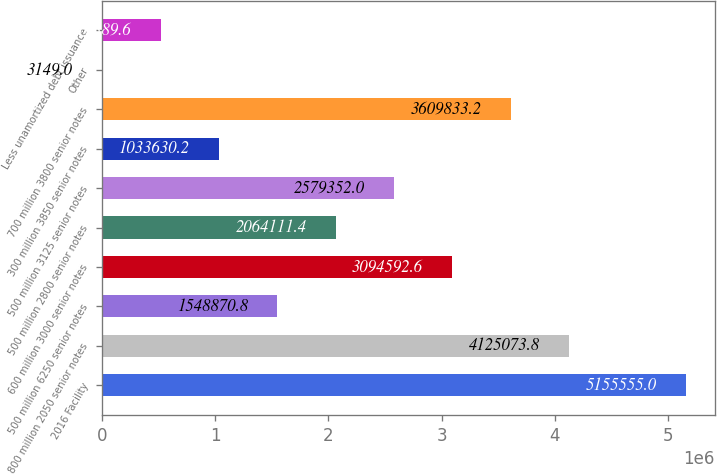Convert chart to OTSL. <chart><loc_0><loc_0><loc_500><loc_500><bar_chart><fcel>2016 Facility<fcel>800 million 2050 senior notes<fcel>500 million 6250 senior notes<fcel>600 million 3000 senior notes<fcel>500 million 2800 senior notes<fcel>500 million 3125 senior notes<fcel>300 million 3850 senior notes<fcel>700 million 3800 senior notes<fcel>Other<fcel>Less unamortized debt issuance<nl><fcel>5.15556e+06<fcel>4.12507e+06<fcel>1.54887e+06<fcel>3.09459e+06<fcel>2.06411e+06<fcel>2.57935e+06<fcel>1.03363e+06<fcel>3.60983e+06<fcel>3149<fcel>518390<nl></chart> 